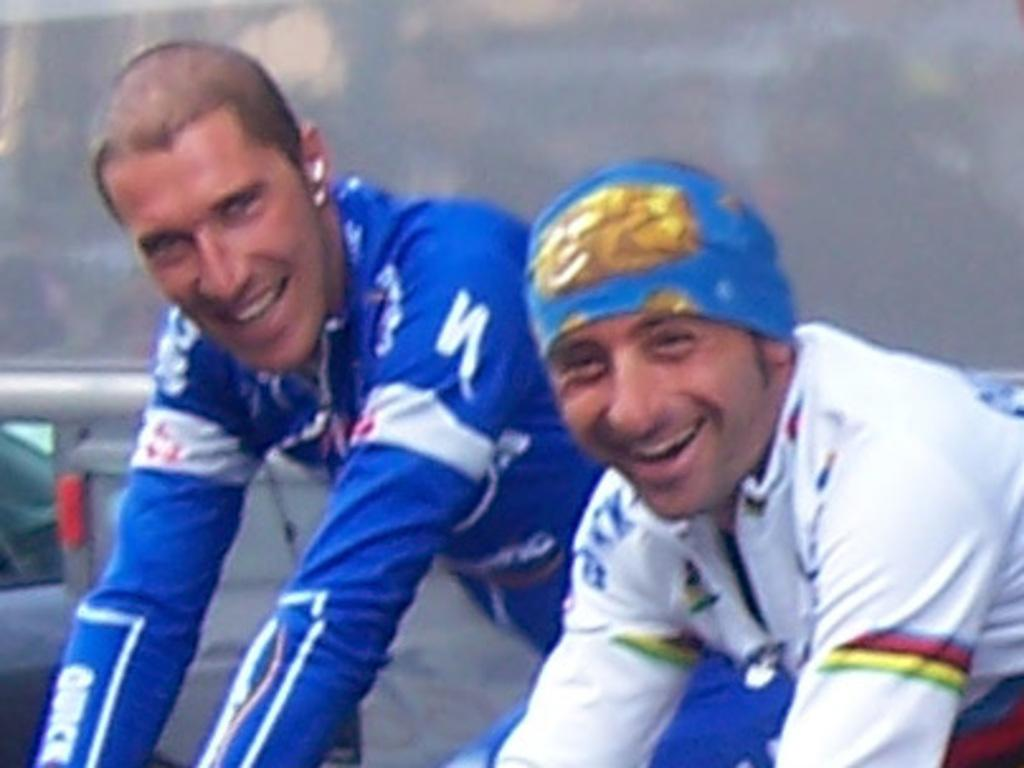How many people are in the image? There are two people in the image. What are the two people wearing? The two people are wearing clothes. What are the two people doing in the image? The two people are standing. What type of plant is growing on the head of one of the people in the image? There is no plant growing on the head of either person in the image. 